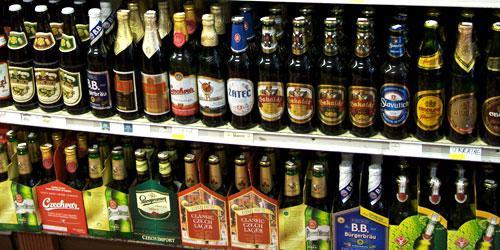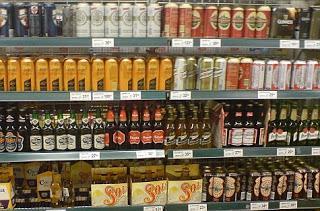The first image is the image on the left, the second image is the image on the right. For the images shown, is this caption "One of the images includes fewer than eight bottles in total." true? Answer yes or no. No. 